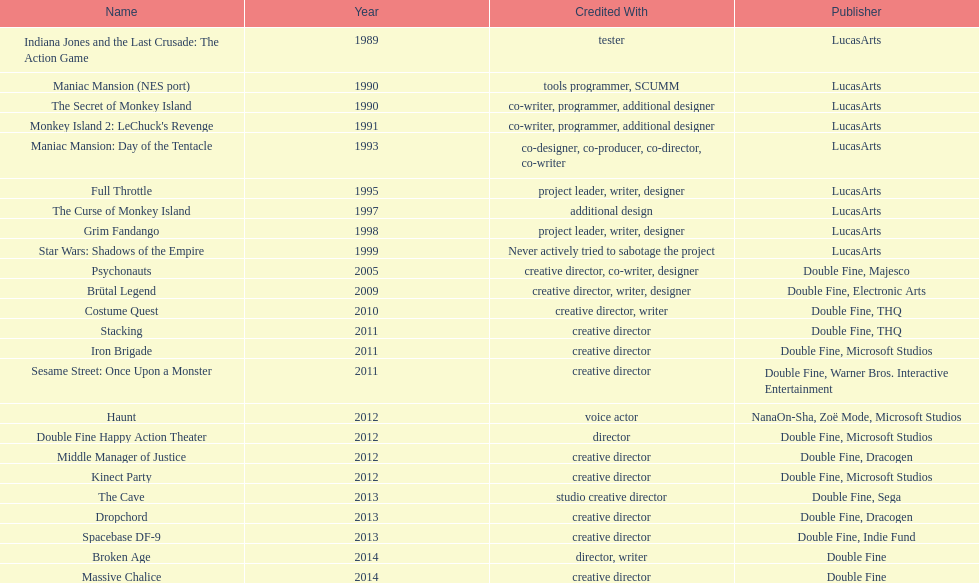Which game is accredited to a creative director and warner bros. interactive entertainment as their imaginative director? Sesame Street: Once Upon a Monster. 